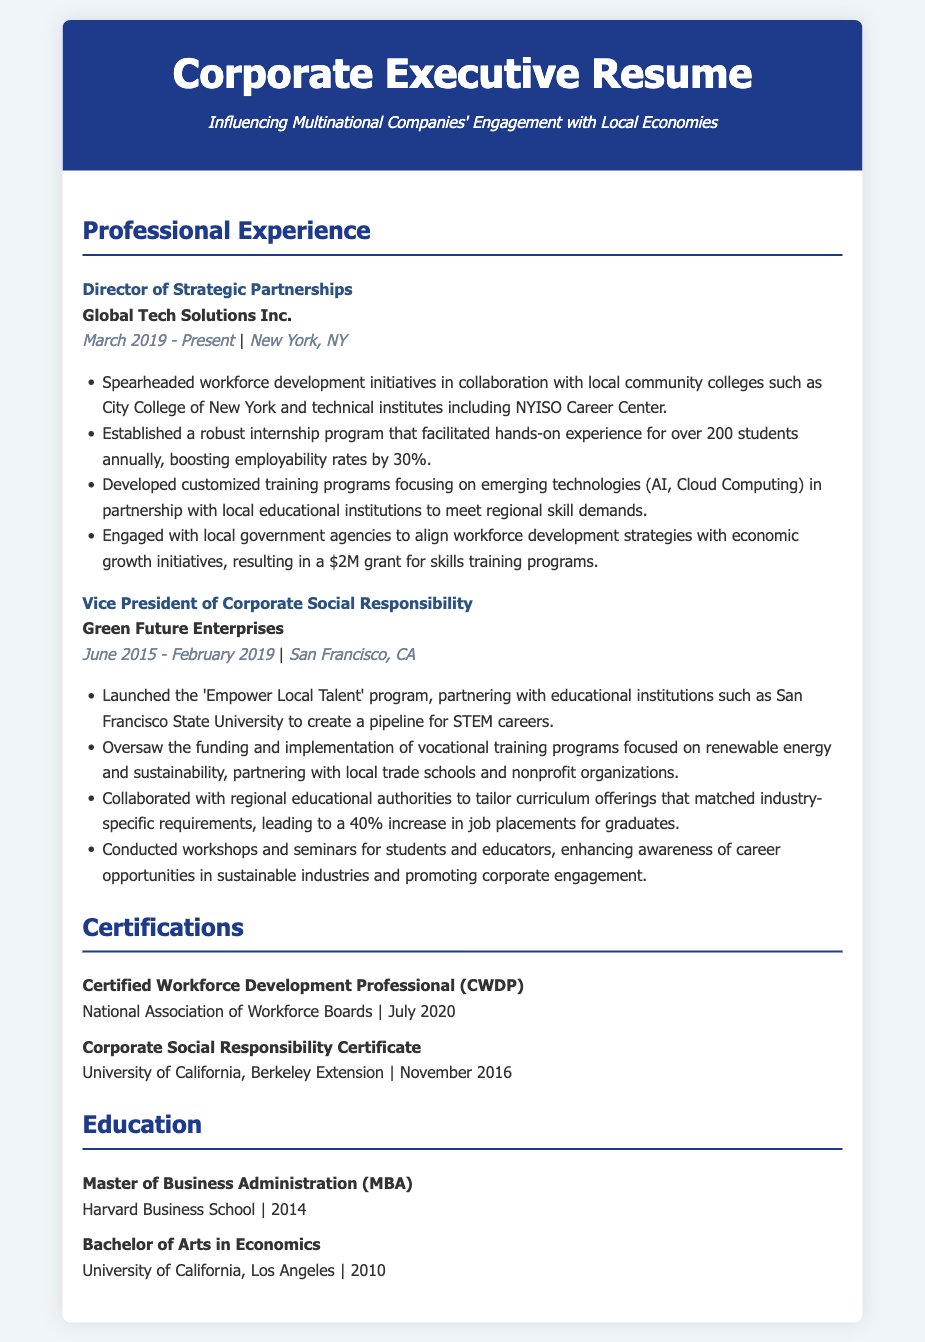what is the job title of the person at Global Tech Solutions Inc.? The job title mentioned in the document for the position at Global Tech Solutions Inc. is "Director of Strategic Partnerships."
Answer: Director of Strategic Partnerships which company did the Vice President of Corporate Social Responsibility work for? In the document, the Vice President of Corporate Social Responsibility is associated with "Green Future Enterprises."
Answer: Green Future Enterprises how many students participate in the internship program established at Global Tech Solutions Inc.? The document states that the internship program facilitated hands-on experience for "over 200 students annually."
Answer: over 200 students what percentage increase in job placements for graduates resulted from the collaboration with regional educational authorities? The document indicates a "40% increase in job placements for graduates" due to the tailored curriculum offerings.
Answer: 40% what year was the Master of Business Administration degree obtained? According to the document, the Master of Business Administration was obtained in "2014."
Answer: 2014 what specific certification was earned in July 2020? The document lists the certification earned in July 2020 as "Certified Workforce Development Professional (CWDP)."
Answer: Certified Workforce Development Professional (CWDP) how much grant was secured for skills training programs? The document mentions a "$2M grant for skills training programs" that was secured.
Answer: $2M which educational institution partnered for the 'Empower Local Talent' program? The document states that the 'Empower Local Talent' program partnered with "San Francisco State University."
Answer: San Francisco State University 